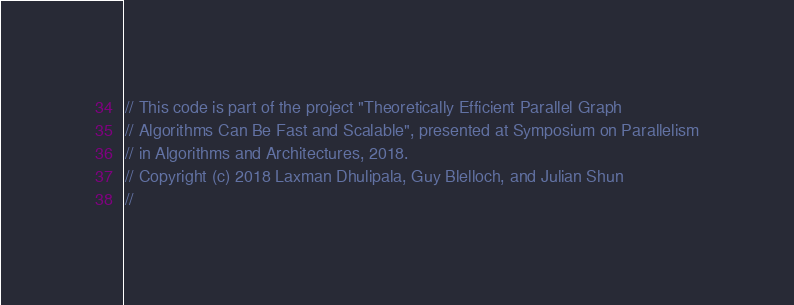<code> <loc_0><loc_0><loc_500><loc_500><_C_>// This code is part of the project "Theoretically Efficient Parallel Graph
// Algorithms Can Be Fast and Scalable", presented at Symposium on Parallelism
// in Algorithms and Architectures, 2018.
// Copyright (c) 2018 Laxman Dhulipala, Guy Blelloch, and Julian Shun
//</code> 